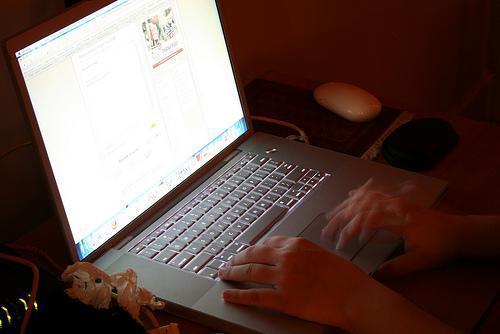How many hands are on the keyboard?
Give a very brief answer. 2. How many cats are there?
Give a very brief answer. 0. 